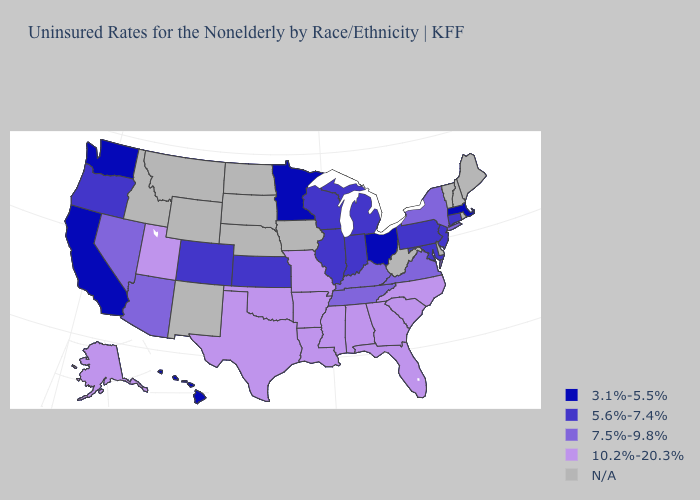Name the states that have a value in the range 3.1%-5.5%?
Be succinct. California, Hawaii, Massachusetts, Minnesota, Ohio, Washington. What is the highest value in states that border Rhode Island?
Write a very short answer. 5.6%-7.4%. Name the states that have a value in the range N/A?
Quick response, please. Delaware, Idaho, Iowa, Maine, Montana, Nebraska, New Hampshire, New Mexico, North Dakota, Rhode Island, South Dakota, Vermont, West Virginia, Wyoming. What is the highest value in states that border Alabama?
Answer briefly. 10.2%-20.3%. Name the states that have a value in the range 3.1%-5.5%?
Answer briefly. California, Hawaii, Massachusetts, Minnesota, Ohio, Washington. What is the value of Massachusetts?
Concise answer only. 3.1%-5.5%. What is the lowest value in the USA?
Write a very short answer. 3.1%-5.5%. Does Kentucky have the highest value in the South?
Give a very brief answer. No. Is the legend a continuous bar?
Be succinct. No. Name the states that have a value in the range 3.1%-5.5%?
Answer briefly. California, Hawaii, Massachusetts, Minnesota, Ohio, Washington. Is the legend a continuous bar?
Be succinct. No. Name the states that have a value in the range 10.2%-20.3%?
Write a very short answer. Alabama, Alaska, Arkansas, Florida, Georgia, Louisiana, Mississippi, Missouri, North Carolina, Oklahoma, South Carolina, Texas, Utah. What is the value of Connecticut?
Write a very short answer. 5.6%-7.4%. Does New York have the lowest value in the Northeast?
Keep it brief. No. Which states have the lowest value in the USA?
Short answer required. California, Hawaii, Massachusetts, Minnesota, Ohio, Washington. 